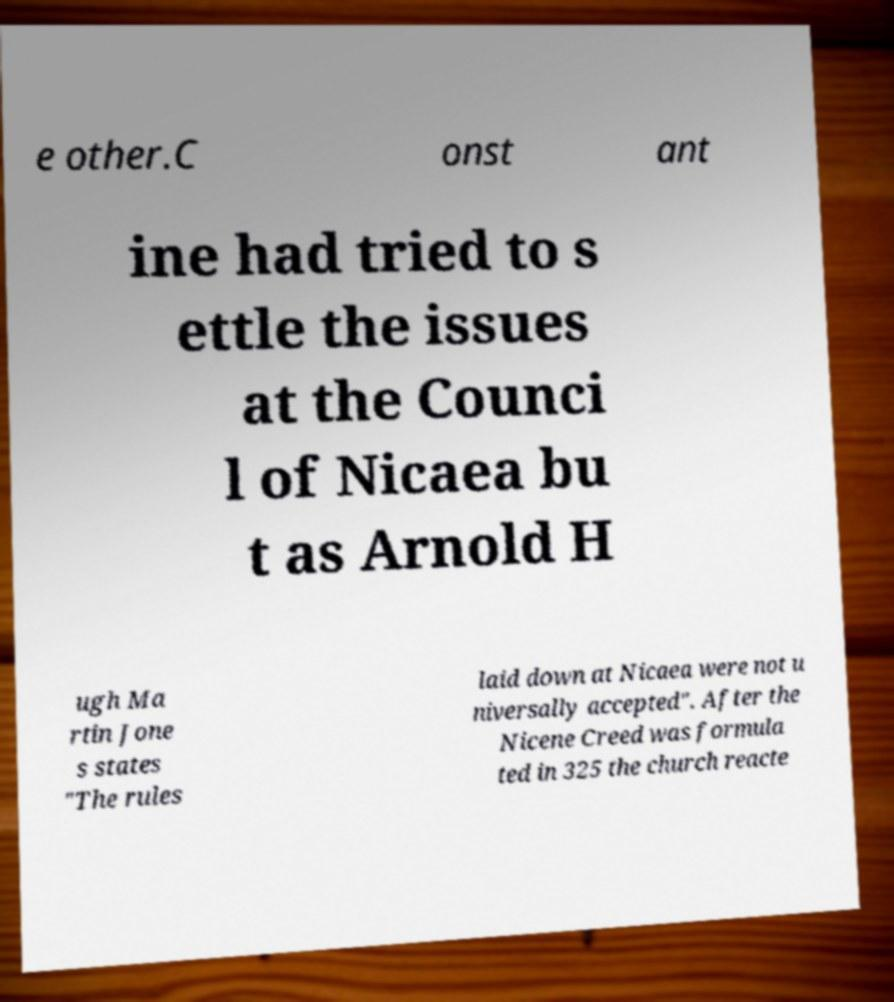Please identify and transcribe the text found in this image. e other.C onst ant ine had tried to s ettle the issues at the Counci l of Nicaea bu t as Arnold H ugh Ma rtin Jone s states "The rules laid down at Nicaea were not u niversally accepted". After the Nicene Creed was formula ted in 325 the church reacte 